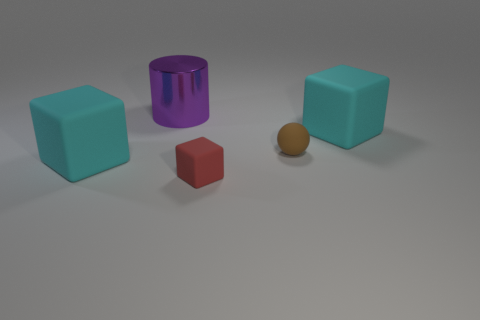Add 2 metallic cylinders. How many objects exist? 7 Subtract all cylinders. How many objects are left? 4 Add 5 big metallic things. How many big metallic things are left? 6 Add 3 big cyan metal things. How many big cyan metal things exist? 3 Subtract 0 cyan spheres. How many objects are left? 5 Subtract all large purple rubber things. Subtract all tiny spheres. How many objects are left? 4 